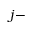<formula> <loc_0><loc_0><loc_500><loc_500>j -</formula> 